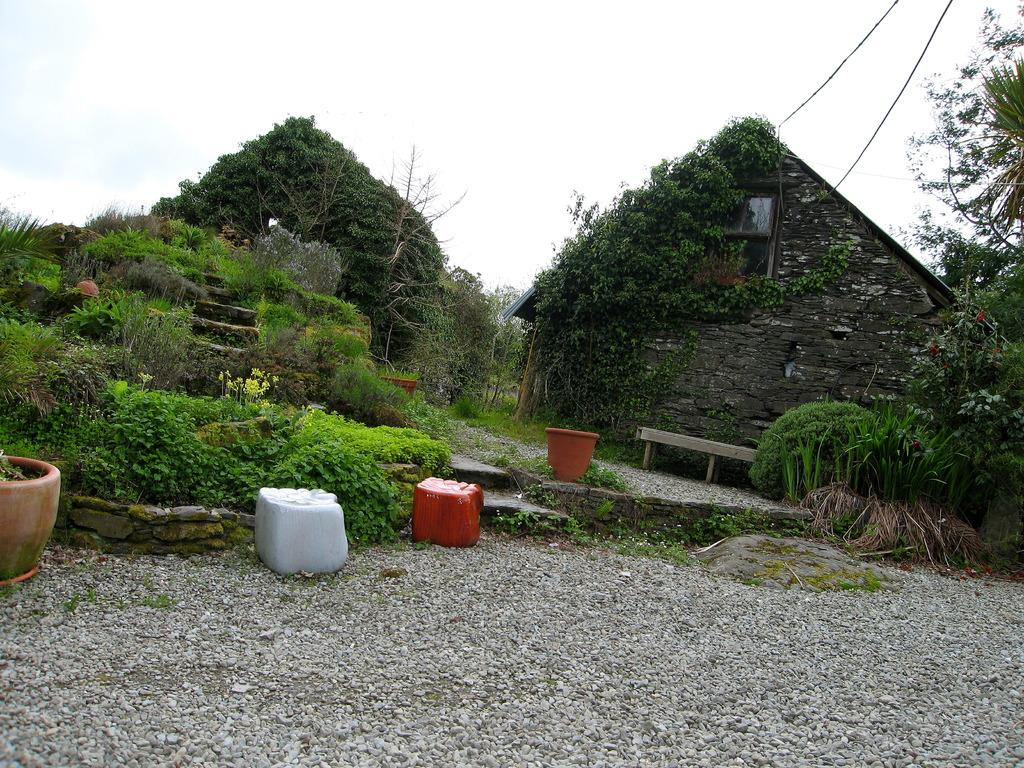What type of structure is visible in the image? There is a house in the image. What other natural elements can be seen in the image? There are plants, trees, and stones visible in the image. What objects are present in the image that might be used for gardening or decoration? There are pots in the image. What is visible in the background of the image? The sky is visible in the background of the image. What type of list can be seen hanging on the wall in the image? There is no list visible in the image; it only features a house, plants, trees, pots, stones, and the sky in the background. Can you tell me how many cherries are on the tree in the image? There are no cherries present in the image; it only features a house, plants, trees, pots, stones, and the sky in the background. 